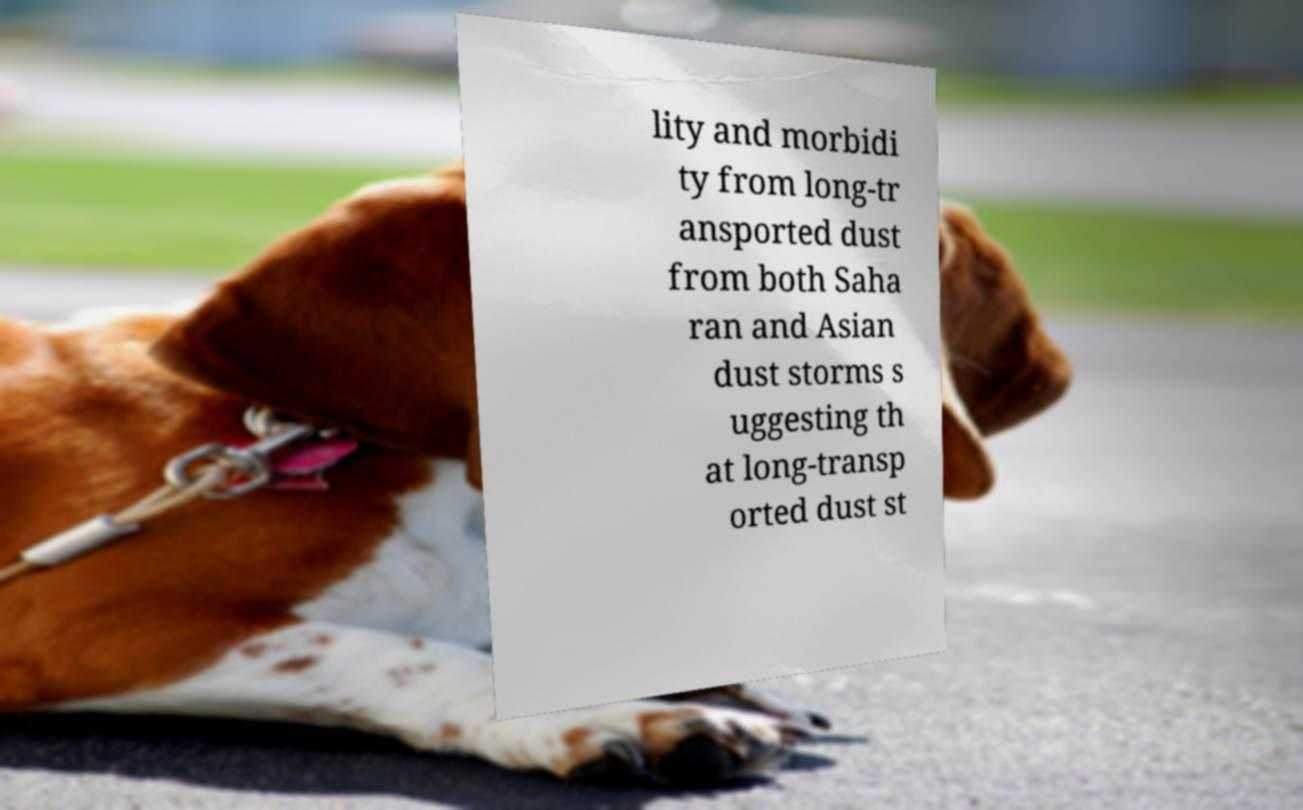Please read and relay the text visible in this image. What does it say? lity and morbidi ty from long-tr ansported dust from both Saha ran and Asian dust storms s uggesting th at long-transp orted dust st 